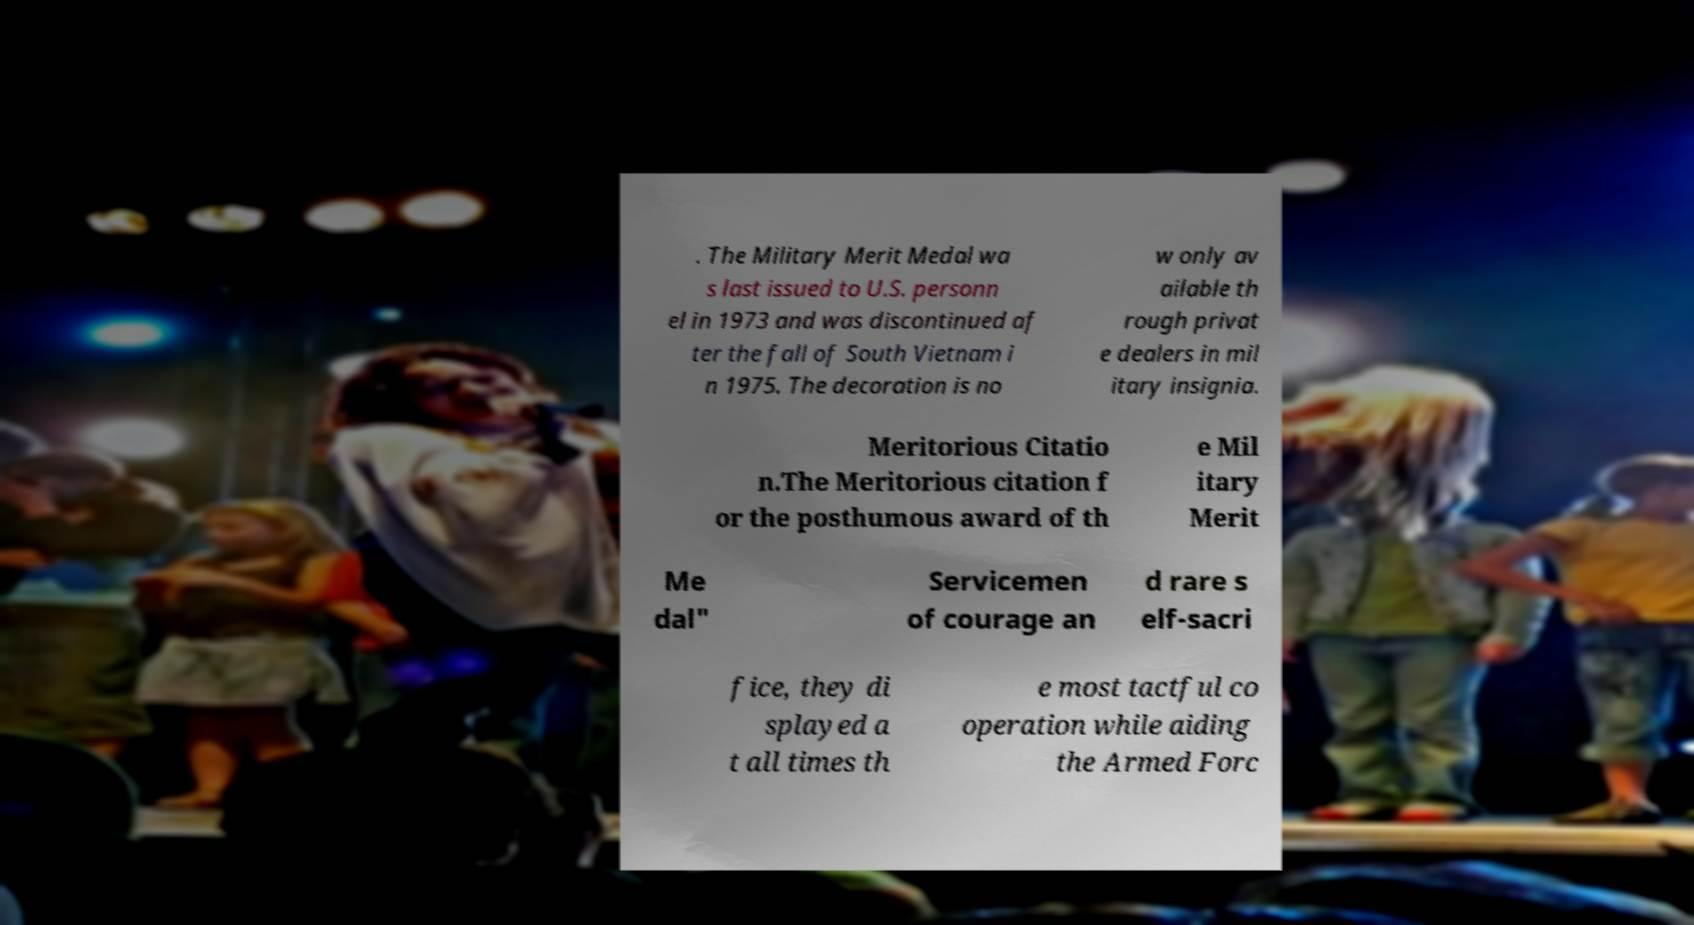Please identify and transcribe the text found in this image. . The Military Merit Medal wa s last issued to U.S. personn el in 1973 and was discontinued af ter the fall of South Vietnam i n 1975. The decoration is no w only av ailable th rough privat e dealers in mil itary insignia. Meritorious Citatio n.The Meritorious citation f or the posthumous award of th e Mil itary Merit Me dal" Servicemen of courage an d rare s elf-sacri fice, they di splayed a t all times th e most tactful co operation while aiding the Armed Forc 